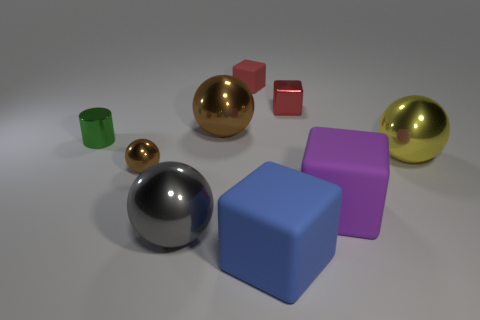Subtract all yellow cylinders. How many red blocks are left? 2 Subtract all yellow spheres. How many spheres are left? 3 Subtract 2 balls. How many balls are left? 2 Subtract all gray spheres. How many spheres are left? 3 Subtract all purple spheres. Subtract all gray cubes. How many spheres are left? 4 Add 1 big blocks. How many objects exist? 10 Subtract all spheres. How many objects are left? 5 Add 8 small red shiny things. How many small red shiny things exist? 9 Subtract 1 purple blocks. How many objects are left? 8 Subtract all gray balls. Subtract all big gray spheres. How many objects are left? 7 